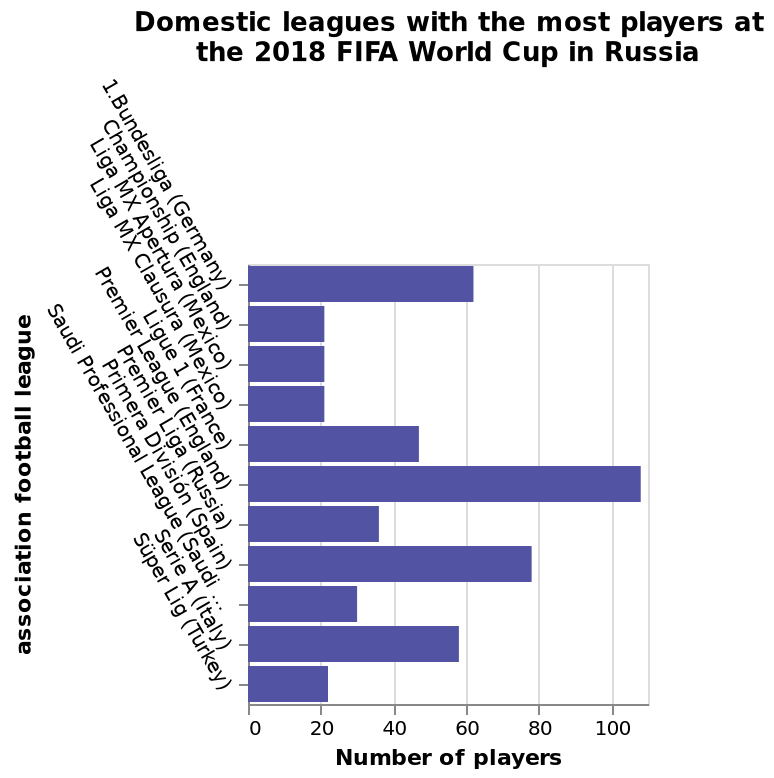<image>
please enumerates aspects of the construction of the chart Here a bar diagram is named Domestic leagues with the most players at the 2018 FIFA World Cup in Russia. The x-axis plots Number of players along linear scale with a minimum of 0 and a maximum of 100 while the y-axis shows association football league with categorical scale starting with 1.Bundesliga (Germany) and ending with Süper Lig (Turkey). What type of scale is used for the y-axis of the bar diagram? The y-axis uses a categorical scale, starting with 1.Bundesliga (Germany) and ending with Süper Lig (Turkey). What is the name of the bar diagram?  The bar diagram is named "Domestic leagues with the most players at the 2018 FIFA World Cup in Russia." 